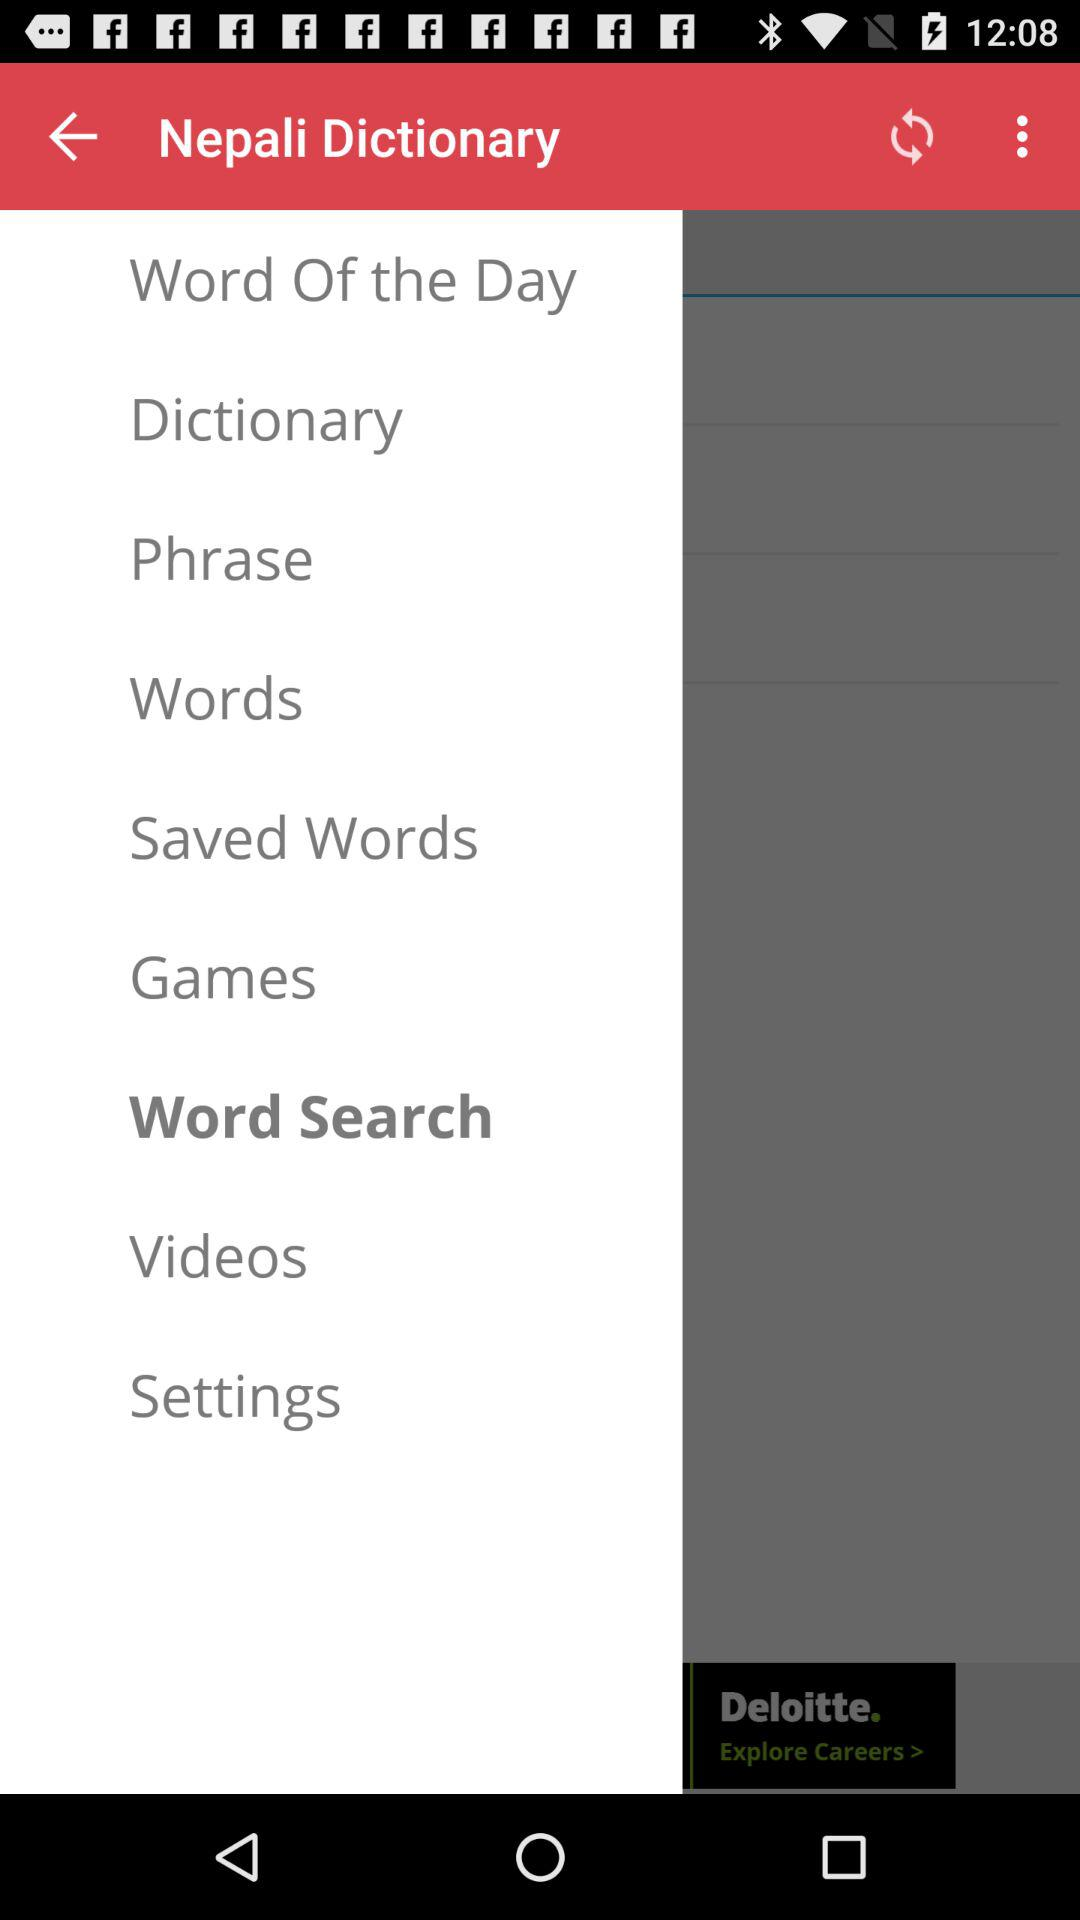What is the language of the dictionary? The language of the dictionary is Nepali. 